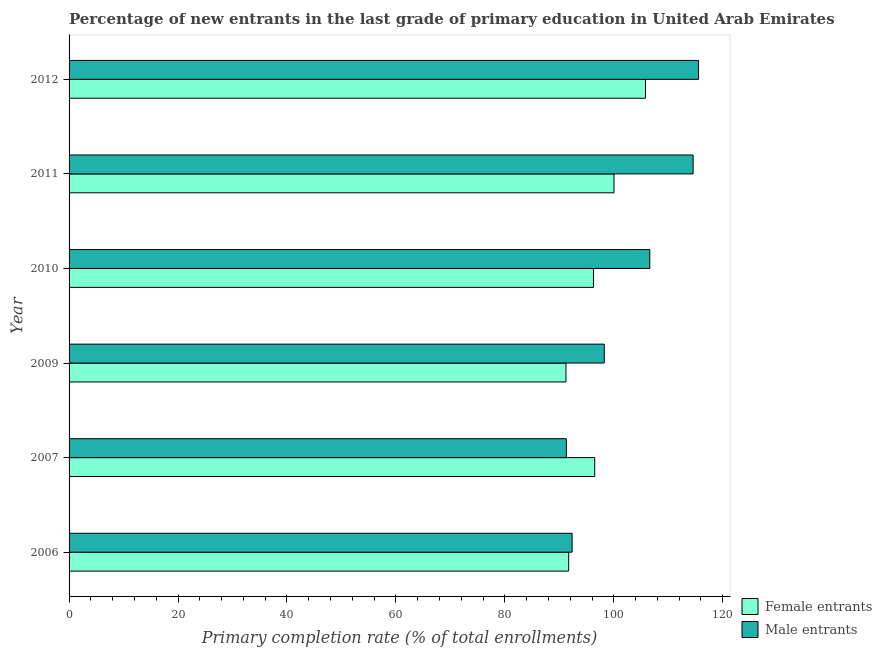Are the number of bars per tick equal to the number of legend labels?
Your answer should be compact. Yes. Are the number of bars on each tick of the Y-axis equal?
Provide a succinct answer. Yes. In how many cases, is the number of bars for a given year not equal to the number of legend labels?
Keep it short and to the point. 0. What is the primary completion rate of female entrants in 2007?
Make the answer very short. 96.5. Across all years, what is the maximum primary completion rate of female entrants?
Your answer should be compact. 105.82. Across all years, what is the minimum primary completion rate of male entrants?
Offer a very short reply. 91.29. What is the total primary completion rate of female entrants in the graph?
Your answer should be very brief. 581.57. What is the difference between the primary completion rate of female entrants in 2007 and that in 2009?
Offer a very short reply. 5.28. What is the difference between the primary completion rate of male entrants in 2011 and the primary completion rate of female entrants in 2009?
Give a very brief answer. 23.34. What is the average primary completion rate of male entrants per year?
Make the answer very short. 103.1. In the year 2009, what is the difference between the primary completion rate of male entrants and primary completion rate of female entrants?
Your answer should be compact. 7.03. What is the ratio of the primary completion rate of female entrants in 2009 to that in 2011?
Keep it short and to the point. 0.91. What is the difference between the highest and the second highest primary completion rate of female entrants?
Your response must be concise. 5.78. What is the difference between the highest and the lowest primary completion rate of female entrants?
Your answer should be compact. 14.6. In how many years, is the primary completion rate of female entrants greater than the average primary completion rate of female entrants taken over all years?
Offer a very short reply. 2. What does the 2nd bar from the top in 2007 represents?
Offer a terse response. Female entrants. What does the 1st bar from the bottom in 2012 represents?
Offer a very short reply. Female entrants. How many bars are there?
Ensure brevity in your answer.  12. Are all the bars in the graph horizontal?
Your answer should be very brief. Yes. Does the graph contain grids?
Give a very brief answer. No. Where does the legend appear in the graph?
Ensure brevity in your answer.  Bottom right. How many legend labels are there?
Make the answer very short. 2. How are the legend labels stacked?
Offer a terse response. Vertical. What is the title of the graph?
Offer a terse response. Percentage of new entrants in the last grade of primary education in United Arab Emirates. What is the label or title of the X-axis?
Provide a short and direct response. Primary completion rate (% of total enrollments). What is the Primary completion rate (% of total enrollments) of Female entrants in 2006?
Offer a terse response. 91.72. What is the Primary completion rate (% of total enrollments) in Male entrants in 2006?
Provide a succinct answer. 92.35. What is the Primary completion rate (% of total enrollments) of Female entrants in 2007?
Provide a short and direct response. 96.5. What is the Primary completion rate (% of total enrollments) of Male entrants in 2007?
Keep it short and to the point. 91.29. What is the Primary completion rate (% of total enrollments) of Female entrants in 2009?
Your answer should be compact. 91.22. What is the Primary completion rate (% of total enrollments) in Male entrants in 2009?
Your answer should be compact. 98.25. What is the Primary completion rate (% of total enrollments) in Female entrants in 2010?
Ensure brevity in your answer.  96.27. What is the Primary completion rate (% of total enrollments) in Male entrants in 2010?
Give a very brief answer. 106.61. What is the Primary completion rate (% of total enrollments) in Female entrants in 2011?
Provide a succinct answer. 100.04. What is the Primary completion rate (% of total enrollments) of Male entrants in 2011?
Give a very brief answer. 114.56. What is the Primary completion rate (% of total enrollments) of Female entrants in 2012?
Offer a terse response. 105.82. What is the Primary completion rate (% of total enrollments) in Male entrants in 2012?
Provide a short and direct response. 115.56. Across all years, what is the maximum Primary completion rate (% of total enrollments) of Female entrants?
Offer a very short reply. 105.82. Across all years, what is the maximum Primary completion rate (% of total enrollments) of Male entrants?
Provide a short and direct response. 115.56. Across all years, what is the minimum Primary completion rate (% of total enrollments) of Female entrants?
Your answer should be very brief. 91.22. Across all years, what is the minimum Primary completion rate (% of total enrollments) in Male entrants?
Offer a very short reply. 91.29. What is the total Primary completion rate (% of total enrollments) in Female entrants in the graph?
Provide a short and direct response. 581.57. What is the total Primary completion rate (% of total enrollments) of Male entrants in the graph?
Offer a very short reply. 618.62. What is the difference between the Primary completion rate (% of total enrollments) of Female entrants in 2006 and that in 2007?
Provide a short and direct response. -4.78. What is the difference between the Primary completion rate (% of total enrollments) in Male entrants in 2006 and that in 2007?
Provide a succinct answer. 1.06. What is the difference between the Primary completion rate (% of total enrollments) in Female entrants in 2006 and that in 2009?
Offer a very short reply. 0.5. What is the difference between the Primary completion rate (% of total enrollments) of Male entrants in 2006 and that in 2009?
Provide a succinct answer. -5.9. What is the difference between the Primary completion rate (% of total enrollments) in Female entrants in 2006 and that in 2010?
Ensure brevity in your answer.  -4.55. What is the difference between the Primary completion rate (% of total enrollments) in Male entrants in 2006 and that in 2010?
Ensure brevity in your answer.  -14.26. What is the difference between the Primary completion rate (% of total enrollments) of Female entrants in 2006 and that in 2011?
Your answer should be very brief. -8.32. What is the difference between the Primary completion rate (% of total enrollments) in Male entrants in 2006 and that in 2011?
Make the answer very short. -22.22. What is the difference between the Primary completion rate (% of total enrollments) in Female entrants in 2006 and that in 2012?
Make the answer very short. -14.1. What is the difference between the Primary completion rate (% of total enrollments) in Male entrants in 2006 and that in 2012?
Ensure brevity in your answer.  -23.21. What is the difference between the Primary completion rate (% of total enrollments) of Female entrants in 2007 and that in 2009?
Give a very brief answer. 5.28. What is the difference between the Primary completion rate (% of total enrollments) in Male entrants in 2007 and that in 2009?
Provide a short and direct response. -6.96. What is the difference between the Primary completion rate (% of total enrollments) of Female entrants in 2007 and that in 2010?
Your response must be concise. 0.23. What is the difference between the Primary completion rate (% of total enrollments) in Male entrants in 2007 and that in 2010?
Provide a succinct answer. -15.32. What is the difference between the Primary completion rate (% of total enrollments) of Female entrants in 2007 and that in 2011?
Your response must be concise. -3.54. What is the difference between the Primary completion rate (% of total enrollments) of Male entrants in 2007 and that in 2011?
Offer a terse response. -23.28. What is the difference between the Primary completion rate (% of total enrollments) in Female entrants in 2007 and that in 2012?
Your answer should be compact. -9.32. What is the difference between the Primary completion rate (% of total enrollments) of Male entrants in 2007 and that in 2012?
Provide a short and direct response. -24.27. What is the difference between the Primary completion rate (% of total enrollments) of Female entrants in 2009 and that in 2010?
Provide a succinct answer. -5.05. What is the difference between the Primary completion rate (% of total enrollments) of Male entrants in 2009 and that in 2010?
Ensure brevity in your answer.  -8.36. What is the difference between the Primary completion rate (% of total enrollments) of Female entrants in 2009 and that in 2011?
Offer a terse response. -8.82. What is the difference between the Primary completion rate (% of total enrollments) of Male entrants in 2009 and that in 2011?
Give a very brief answer. -16.31. What is the difference between the Primary completion rate (% of total enrollments) in Female entrants in 2009 and that in 2012?
Provide a short and direct response. -14.6. What is the difference between the Primary completion rate (% of total enrollments) in Male entrants in 2009 and that in 2012?
Provide a succinct answer. -17.31. What is the difference between the Primary completion rate (% of total enrollments) in Female entrants in 2010 and that in 2011?
Give a very brief answer. -3.77. What is the difference between the Primary completion rate (% of total enrollments) of Male entrants in 2010 and that in 2011?
Your answer should be compact. -7.95. What is the difference between the Primary completion rate (% of total enrollments) of Female entrants in 2010 and that in 2012?
Keep it short and to the point. -9.55. What is the difference between the Primary completion rate (% of total enrollments) in Male entrants in 2010 and that in 2012?
Your response must be concise. -8.95. What is the difference between the Primary completion rate (% of total enrollments) of Female entrants in 2011 and that in 2012?
Offer a terse response. -5.78. What is the difference between the Primary completion rate (% of total enrollments) in Male entrants in 2011 and that in 2012?
Make the answer very short. -0.99. What is the difference between the Primary completion rate (% of total enrollments) of Female entrants in 2006 and the Primary completion rate (% of total enrollments) of Male entrants in 2007?
Ensure brevity in your answer.  0.43. What is the difference between the Primary completion rate (% of total enrollments) in Female entrants in 2006 and the Primary completion rate (% of total enrollments) in Male entrants in 2009?
Your response must be concise. -6.53. What is the difference between the Primary completion rate (% of total enrollments) of Female entrants in 2006 and the Primary completion rate (% of total enrollments) of Male entrants in 2010?
Your response must be concise. -14.89. What is the difference between the Primary completion rate (% of total enrollments) in Female entrants in 2006 and the Primary completion rate (% of total enrollments) in Male entrants in 2011?
Give a very brief answer. -22.85. What is the difference between the Primary completion rate (% of total enrollments) in Female entrants in 2006 and the Primary completion rate (% of total enrollments) in Male entrants in 2012?
Your response must be concise. -23.84. What is the difference between the Primary completion rate (% of total enrollments) of Female entrants in 2007 and the Primary completion rate (% of total enrollments) of Male entrants in 2009?
Provide a succinct answer. -1.75. What is the difference between the Primary completion rate (% of total enrollments) of Female entrants in 2007 and the Primary completion rate (% of total enrollments) of Male entrants in 2010?
Keep it short and to the point. -10.11. What is the difference between the Primary completion rate (% of total enrollments) in Female entrants in 2007 and the Primary completion rate (% of total enrollments) in Male entrants in 2011?
Provide a succinct answer. -18.06. What is the difference between the Primary completion rate (% of total enrollments) in Female entrants in 2007 and the Primary completion rate (% of total enrollments) in Male entrants in 2012?
Make the answer very short. -19.06. What is the difference between the Primary completion rate (% of total enrollments) in Female entrants in 2009 and the Primary completion rate (% of total enrollments) in Male entrants in 2010?
Offer a terse response. -15.39. What is the difference between the Primary completion rate (% of total enrollments) of Female entrants in 2009 and the Primary completion rate (% of total enrollments) of Male entrants in 2011?
Offer a very short reply. -23.34. What is the difference between the Primary completion rate (% of total enrollments) of Female entrants in 2009 and the Primary completion rate (% of total enrollments) of Male entrants in 2012?
Offer a very short reply. -24.34. What is the difference between the Primary completion rate (% of total enrollments) of Female entrants in 2010 and the Primary completion rate (% of total enrollments) of Male entrants in 2011?
Provide a short and direct response. -18.29. What is the difference between the Primary completion rate (% of total enrollments) in Female entrants in 2010 and the Primary completion rate (% of total enrollments) in Male entrants in 2012?
Your response must be concise. -19.29. What is the difference between the Primary completion rate (% of total enrollments) in Female entrants in 2011 and the Primary completion rate (% of total enrollments) in Male entrants in 2012?
Your answer should be very brief. -15.52. What is the average Primary completion rate (% of total enrollments) of Female entrants per year?
Ensure brevity in your answer.  96.93. What is the average Primary completion rate (% of total enrollments) in Male entrants per year?
Ensure brevity in your answer.  103.1. In the year 2006, what is the difference between the Primary completion rate (% of total enrollments) of Female entrants and Primary completion rate (% of total enrollments) of Male entrants?
Keep it short and to the point. -0.63. In the year 2007, what is the difference between the Primary completion rate (% of total enrollments) of Female entrants and Primary completion rate (% of total enrollments) of Male entrants?
Give a very brief answer. 5.21. In the year 2009, what is the difference between the Primary completion rate (% of total enrollments) in Female entrants and Primary completion rate (% of total enrollments) in Male entrants?
Offer a terse response. -7.03. In the year 2010, what is the difference between the Primary completion rate (% of total enrollments) in Female entrants and Primary completion rate (% of total enrollments) in Male entrants?
Ensure brevity in your answer.  -10.34. In the year 2011, what is the difference between the Primary completion rate (% of total enrollments) in Female entrants and Primary completion rate (% of total enrollments) in Male entrants?
Provide a short and direct response. -14.53. In the year 2012, what is the difference between the Primary completion rate (% of total enrollments) in Female entrants and Primary completion rate (% of total enrollments) in Male entrants?
Provide a succinct answer. -9.74. What is the ratio of the Primary completion rate (% of total enrollments) of Female entrants in 2006 to that in 2007?
Give a very brief answer. 0.95. What is the ratio of the Primary completion rate (% of total enrollments) of Male entrants in 2006 to that in 2007?
Provide a short and direct response. 1.01. What is the ratio of the Primary completion rate (% of total enrollments) of Male entrants in 2006 to that in 2009?
Offer a very short reply. 0.94. What is the ratio of the Primary completion rate (% of total enrollments) of Female entrants in 2006 to that in 2010?
Keep it short and to the point. 0.95. What is the ratio of the Primary completion rate (% of total enrollments) of Male entrants in 2006 to that in 2010?
Give a very brief answer. 0.87. What is the ratio of the Primary completion rate (% of total enrollments) of Female entrants in 2006 to that in 2011?
Provide a short and direct response. 0.92. What is the ratio of the Primary completion rate (% of total enrollments) of Male entrants in 2006 to that in 2011?
Provide a succinct answer. 0.81. What is the ratio of the Primary completion rate (% of total enrollments) in Female entrants in 2006 to that in 2012?
Your answer should be very brief. 0.87. What is the ratio of the Primary completion rate (% of total enrollments) of Male entrants in 2006 to that in 2012?
Offer a very short reply. 0.8. What is the ratio of the Primary completion rate (% of total enrollments) in Female entrants in 2007 to that in 2009?
Provide a short and direct response. 1.06. What is the ratio of the Primary completion rate (% of total enrollments) of Male entrants in 2007 to that in 2009?
Give a very brief answer. 0.93. What is the ratio of the Primary completion rate (% of total enrollments) of Male entrants in 2007 to that in 2010?
Offer a very short reply. 0.86. What is the ratio of the Primary completion rate (% of total enrollments) of Female entrants in 2007 to that in 2011?
Your answer should be compact. 0.96. What is the ratio of the Primary completion rate (% of total enrollments) of Male entrants in 2007 to that in 2011?
Ensure brevity in your answer.  0.8. What is the ratio of the Primary completion rate (% of total enrollments) of Female entrants in 2007 to that in 2012?
Your answer should be compact. 0.91. What is the ratio of the Primary completion rate (% of total enrollments) of Male entrants in 2007 to that in 2012?
Provide a short and direct response. 0.79. What is the ratio of the Primary completion rate (% of total enrollments) of Female entrants in 2009 to that in 2010?
Ensure brevity in your answer.  0.95. What is the ratio of the Primary completion rate (% of total enrollments) in Male entrants in 2009 to that in 2010?
Your response must be concise. 0.92. What is the ratio of the Primary completion rate (% of total enrollments) in Female entrants in 2009 to that in 2011?
Your answer should be very brief. 0.91. What is the ratio of the Primary completion rate (% of total enrollments) of Male entrants in 2009 to that in 2011?
Ensure brevity in your answer.  0.86. What is the ratio of the Primary completion rate (% of total enrollments) in Female entrants in 2009 to that in 2012?
Ensure brevity in your answer.  0.86. What is the ratio of the Primary completion rate (% of total enrollments) of Male entrants in 2009 to that in 2012?
Give a very brief answer. 0.85. What is the ratio of the Primary completion rate (% of total enrollments) in Female entrants in 2010 to that in 2011?
Keep it short and to the point. 0.96. What is the ratio of the Primary completion rate (% of total enrollments) of Male entrants in 2010 to that in 2011?
Keep it short and to the point. 0.93. What is the ratio of the Primary completion rate (% of total enrollments) in Female entrants in 2010 to that in 2012?
Offer a very short reply. 0.91. What is the ratio of the Primary completion rate (% of total enrollments) of Male entrants in 2010 to that in 2012?
Provide a succinct answer. 0.92. What is the ratio of the Primary completion rate (% of total enrollments) in Female entrants in 2011 to that in 2012?
Your response must be concise. 0.95. What is the difference between the highest and the second highest Primary completion rate (% of total enrollments) in Female entrants?
Give a very brief answer. 5.78. What is the difference between the highest and the second highest Primary completion rate (% of total enrollments) in Male entrants?
Keep it short and to the point. 0.99. What is the difference between the highest and the lowest Primary completion rate (% of total enrollments) of Female entrants?
Make the answer very short. 14.6. What is the difference between the highest and the lowest Primary completion rate (% of total enrollments) in Male entrants?
Offer a very short reply. 24.27. 